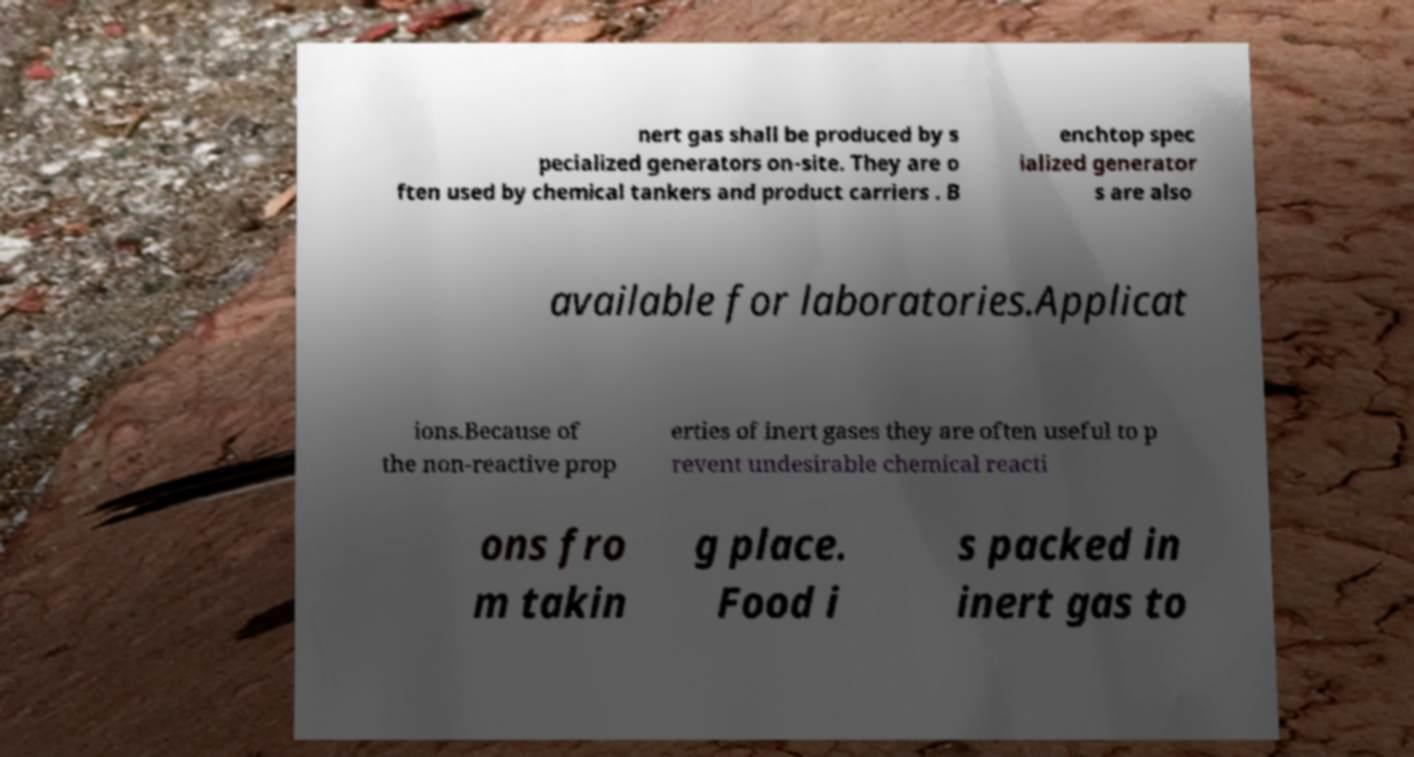Please read and relay the text visible in this image. What does it say? nert gas shall be produced by s pecialized generators on-site. They are o ften used by chemical tankers and product carriers . B enchtop spec ialized generator s are also available for laboratories.Applicat ions.Because of the non-reactive prop erties of inert gases they are often useful to p revent undesirable chemical reacti ons fro m takin g place. Food i s packed in inert gas to 